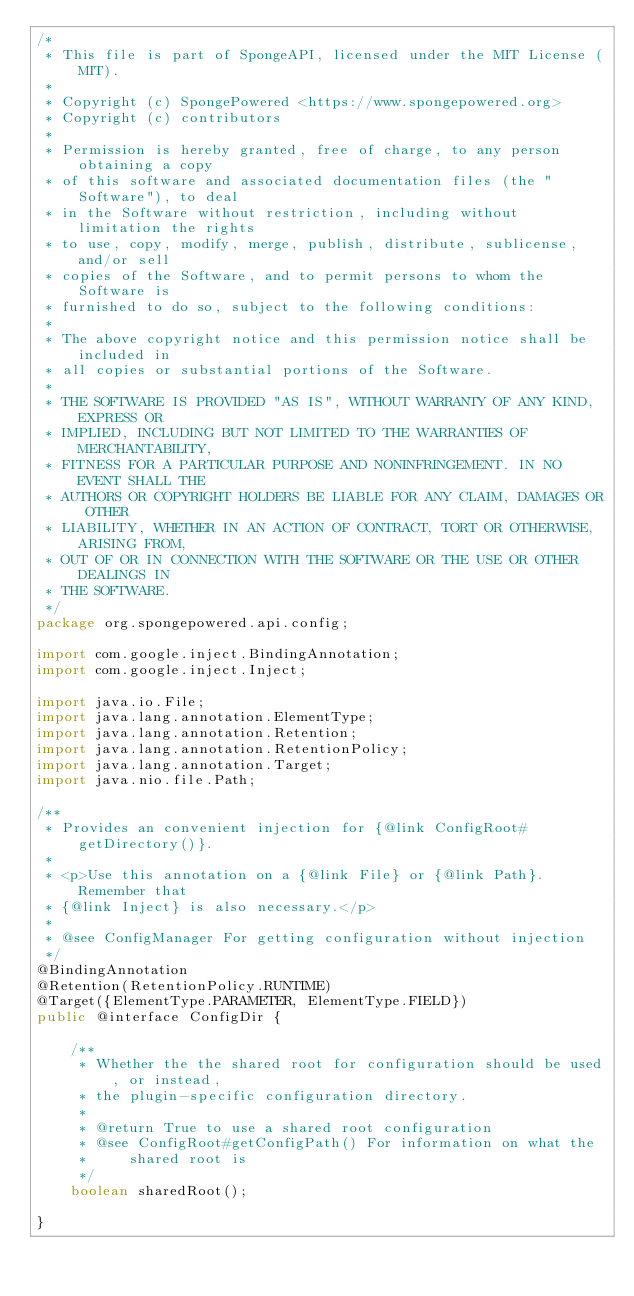Convert code to text. <code><loc_0><loc_0><loc_500><loc_500><_Java_>/*
 * This file is part of SpongeAPI, licensed under the MIT License (MIT).
 *
 * Copyright (c) SpongePowered <https://www.spongepowered.org>
 * Copyright (c) contributors
 *
 * Permission is hereby granted, free of charge, to any person obtaining a copy
 * of this software and associated documentation files (the "Software"), to deal
 * in the Software without restriction, including without limitation the rights
 * to use, copy, modify, merge, publish, distribute, sublicense, and/or sell
 * copies of the Software, and to permit persons to whom the Software is
 * furnished to do so, subject to the following conditions:
 *
 * The above copyright notice and this permission notice shall be included in
 * all copies or substantial portions of the Software.
 *
 * THE SOFTWARE IS PROVIDED "AS IS", WITHOUT WARRANTY OF ANY KIND, EXPRESS OR
 * IMPLIED, INCLUDING BUT NOT LIMITED TO THE WARRANTIES OF MERCHANTABILITY,
 * FITNESS FOR A PARTICULAR PURPOSE AND NONINFRINGEMENT. IN NO EVENT SHALL THE
 * AUTHORS OR COPYRIGHT HOLDERS BE LIABLE FOR ANY CLAIM, DAMAGES OR OTHER
 * LIABILITY, WHETHER IN AN ACTION OF CONTRACT, TORT OR OTHERWISE, ARISING FROM,
 * OUT OF OR IN CONNECTION WITH THE SOFTWARE OR THE USE OR OTHER DEALINGS IN
 * THE SOFTWARE.
 */
package org.spongepowered.api.config;

import com.google.inject.BindingAnnotation;
import com.google.inject.Inject;

import java.io.File;
import java.lang.annotation.ElementType;
import java.lang.annotation.Retention;
import java.lang.annotation.RetentionPolicy;
import java.lang.annotation.Target;
import java.nio.file.Path;

/**
 * Provides an convenient injection for {@link ConfigRoot#getDirectory()}.
 *
 * <p>Use this annotation on a {@link File} or {@link Path}. Remember that
 * {@link Inject} is also necessary.</p>
 *
 * @see ConfigManager For getting configuration without injection
 */
@BindingAnnotation
@Retention(RetentionPolicy.RUNTIME)
@Target({ElementType.PARAMETER, ElementType.FIELD})
public @interface ConfigDir {

    /**
     * Whether the the shared root for configuration should be used, or instead,
     * the plugin-specific configuration directory.
     *
     * @return True to use a shared root configuration
     * @see ConfigRoot#getConfigPath() For information on what the
     *     shared root is
     */
    boolean sharedRoot();

}
</code> 